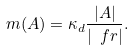Convert formula to latex. <formula><loc_0><loc_0><loc_500><loc_500>\ m ( A ) = \kappa _ { d } \frac { | A | } { | \ f r | } .</formula> 